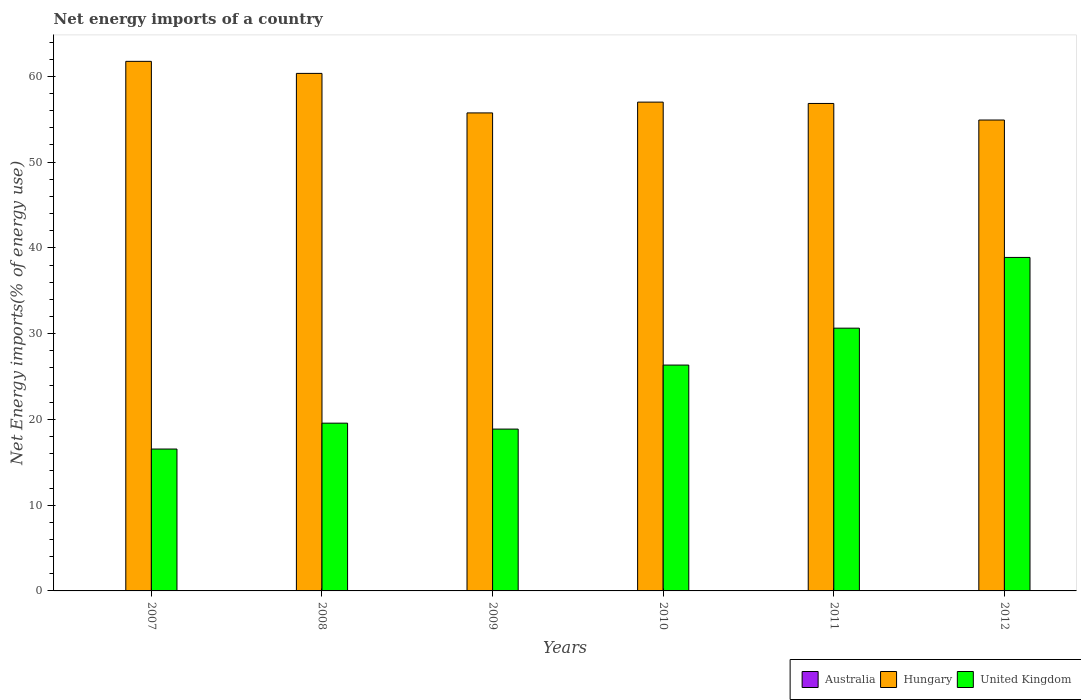Are the number of bars per tick equal to the number of legend labels?
Provide a succinct answer. No. Are the number of bars on each tick of the X-axis equal?
Provide a short and direct response. Yes. How many bars are there on the 2nd tick from the left?
Your answer should be very brief. 2. How many bars are there on the 1st tick from the right?
Provide a short and direct response. 2. What is the label of the 5th group of bars from the left?
Offer a terse response. 2011. In how many cases, is the number of bars for a given year not equal to the number of legend labels?
Make the answer very short. 6. Across all years, what is the maximum net energy imports in Hungary?
Your response must be concise. 61.75. Across all years, what is the minimum net energy imports in Australia?
Offer a very short reply. 0. In which year was the net energy imports in Hungary maximum?
Give a very brief answer. 2007. What is the total net energy imports in Hungary in the graph?
Make the answer very short. 346.56. What is the difference between the net energy imports in Hungary in 2011 and that in 2012?
Keep it short and to the point. 1.93. What is the difference between the net energy imports in United Kingdom in 2008 and the net energy imports in Hungary in 2009?
Keep it short and to the point. -36.18. What is the average net energy imports in United Kingdom per year?
Keep it short and to the point. 25.14. In the year 2008, what is the difference between the net energy imports in United Kingdom and net energy imports in Hungary?
Make the answer very short. -40.78. What is the ratio of the net energy imports in United Kingdom in 2007 to that in 2011?
Your answer should be compact. 0.54. Is the difference between the net energy imports in United Kingdom in 2007 and 2009 greater than the difference between the net energy imports in Hungary in 2007 and 2009?
Give a very brief answer. No. What is the difference between the highest and the second highest net energy imports in Hungary?
Offer a terse response. 1.4. What is the difference between the highest and the lowest net energy imports in Hungary?
Provide a short and direct response. 6.84. In how many years, is the net energy imports in Australia greater than the average net energy imports in Australia taken over all years?
Provide a succinct answer. 0. Is the sum of the net energy imports in Hungary in 2009 and 2011 greater than the maximum net energy imports in United Kingdom across all years?
Offer a very short reply. Yes. Is it the case that in every year, the sum of the net energy imports in Hungary and net energy imports in Australia is greater than the net energy imports in United Kingdom?
Give a very brief answer. Yes. How many bars are there?
Ensure brevity in your answer.  12. Are all the bars in the graph horizontal?
Provide a succinct answer. No. How many years are there in the graph?
Your answer should be very brief. 6. Are the values on the major ticks of Y-axis written in scientific E-notation?
Your answer should be compact. No. Does the graph contain any zero values?
Your response must be concise. Yes. Where does the legend appear in the graph?
Make the answer very short. Bottom right. How many legend labels are there?
Your answer should be very brief. 3. What is the title of the graph?
Offer a terse response. Net energy imports of a country. What is the label or title of the X-axis?
Offer a very short reply. Years. What is the label or title of the Y-axis?
Your answer should be compact. Net Energy imports(% of energy use). What is the Net Energy imports(% of energy use) of Hungary in 2007?
Your answer should be compact. 61.75. What is the Net Energy imports(% of energy use) of United Kingdom in 2007?
Your response must be concise. 16.54. What is the Net Energy imports(% of energy use) of Australia in 2008?
Offer a very short reply. 0. What is the Net Energy imports(% of energy use) of Hungary in 2008?
Your answer should be very brief. 60.34. What is the Net Energy imports(% of energy use) in United Kingdom in 2008?
Ensure brevity in your answer.  19.56. What is the Net Energy imports(% of energy use) in Australia in 2009?
Keep it short and to the point. 0. What is the Net Energy imports(% of energy use) of Hungary in 2009?
Offer a terse response. 55.74. What is the Net Energy imports(% of energy use) of United Kingdom in 2009?
Ensure brevity in your answer.  18.87. What is the Net Energy imports(% of energy use) in Australia in 2010?
Provide a succinct answer. 0. What is the Net Energy imports(% of energy use) in Hungary in 2010?
Provide a succinct answer. 56.99. What is the Net Energy imports(% of energy use) of United Kingdom in 2010?
Your answer should be very brief. 26.33. What is the Net Energy imports(% of energy use) of Australia in 2011?
Offer a terse response. 0. What is the Net Energy imports(% of energy use) of Hungary in 2011?
Offer a very short reply. 56.84. What is the Net Energy imports(% of energy use) of United Kingdom in 2011?
Ensure brevity in your answer.  30.64. What is the Net Energy imports(% of energy use) of Australia in 2012?
Offer a terse response. 0. What is the Net Energy imports(% of energy use) in Hungary in 2012?
Your answer should be very brief. 54.91. What is the Net Energy imports(% of energy use) in United Kingdom in 2012?
Offer a terse response. 38.88. Across all years, what is the maximum Net Energy imports(% of energy use) of Hungary?
Keep it short and to the point. 61.75. Across all years, what is the maximum Net Energy imports(% of energy use) of United Kingdom?
Offer a terse response. 38.88. Across all years, what is the minimum Net Energy imports(% of energy use) in Hungary?
Keep it short and to the point. 54.91. Across all years, what is the minimum Net Energy imports(% of energy use) in United Kingdom?
Your answer should be compact. 16.54. What is the total Net Energy imports(% of energy use) in Hungary in the graph?
Provide a succinct answer. 346.56. What is the total Net Energy imports(% of energy use) of United Kingdom in the graph?
Offer a terse response. 150.83. What is the difference between the Net Energy imports(% of energy use) in Hungary in 2007 and that in 2008?
Offer a terse response. 1.4. What is the difference between the Net Energy imports(% of energy use) of United Kingdom in 2007 and that in 2008?
Your answer should be very brief. -3.02. What is the difference between the Net Energy imports(% of energy use) in Hungary in 2007 and that in 2009?
Your answer should be very brief. 6.01. What is the difference between the Net Energy imports(% of energy use) of United Kingdom in 2007 and that in 2009?
Ensure brevity in your answer.  -2.33. What is the difference between the Net Energy imports(% of energy use) in Hungary in 2007 and that in 2010?
Provide a succinct answer. 4.75. What is the difference between the Net Energy imports(% of energy use) of United Kingdom in 2007 and that in 2010?
Keep it short and to the point. -9.79. What is the difference between the Net Energy imports(% of energy use) in Hungary in 2007 and that in 2011?
Provide a short and direct response. 4.91. What is the difference between the Net Energy imports(% of energy use) in United Kingdom in 2007 and that in 2011?
Your answer should be compact. -14.09. What is the difference between the Net Energy imports(% of energy use) in Hungary in 2007 and that in 2012?
Keep it short and to the point. 6.84. What is the difference between the Net Energy imports(% of energy use) in United Kingdom in 2007 and that in 2012?
Provide a succinct answer. -22.34. What is the difference between the Net Energy imports(% of energy use) of Hungary in 2008 and that in 2009?
Provide a succinct answer. 4.61. What is the difference between the Net Energy imports(% of energy use) of United Kingdom in 2008 and that in 2009?
Give a very brief answer. 0.69. What is the difference between the Net Energy imports(% of energy use) of Hungary in 2008 and that in 2010?
Provide a short and direct response. 3.35. What is the difference between the Net Energy imports(% of energy use) in United Kingdom in 2008 and that in 2010?
Offer a very short reply. -6.77. What is the difference between the Net Energy imports(% of energy use) of Hungary in 2008 and that in 2011?
Offer a terse response. 3.51. What is the difference between the Net Energy imports(% of energy use) of United Kingdom in 2008 and that in 2011?
Provide a succinct answer. -11.08. What is the difference between the Net Energy imports(% of energy use) in Hungary in 2008 and that in 2012?
Offer a very short reply. 5.43. What is the difference between the Net Energy imports(% of energy use) of United Kingdom in 2008 and that in 2012?
Keep it short and to the point. -19.32. What is the difference between the Net Energy imports(% of energy use) in Hungary in 2009 and that in 2010?
Provide a short and direct response. -1.26. What is the difference between the Net Energy imports(% of energy use) in United Kingdom in 2009 and that in 2010?
Your answer should be very brief. -7.46. What is the difference between the Net Energy imports(% of energy use) of Hungary in 2009 and that in 2011?
Offer a terse response. -1.1. What is the difference between the Net Energy imports(% of energy use) of United Kingdom in 2009 and that in 2011?
Make the answer very short. -11.77. What is the difference between the Net Energy imports(% of energy use) in Hungary in 2009 and that in 2012?
Make the answer very short. 0.83. What is the difference between the Net Energy imports(% of energy use) of United Kingdom in 2009 and that in 2012?
Keep it short and to the point. -20.01. What is the difference between the Net Energy imports(% of energy use) of Hungary in 2010 and that in 2011?
Your response must be concise. 0.16. What is the difference between the Net Energy imports(% of energy use) in United Kingdom in 2010 and that in 2011?
Offer a terse response. -4.3. What is the difference between the Net Energy imports(% of energy use) of Hungary in 2010 and that in 2012?
Ensure brevity in your answer.  2.09. What is the difference between the Net Energy imports(% of energy use) in United Kingdom in 2010 and that in 2012?
Ensure brevity in your answer.  -12.55. What is the difference between the Net Energy imports(% of energy use) of Hungary in 2011 and that in 2012?
Give a very brief answer. 1.93. What is the difference between the Net Energy imports(% of energy use) in United Kingdom in 2011 and that in 2012?
Provide a short and direct response. -8.25. What is the difference between the Net Energy imports(% of energy use) in Hungary in 2007 and the Net Energy imports(% of energy use) in United Kingdom in 2008?
Your answer should be very brief. 42.19. What is the difference between the Net Energy imports(% of energy use) of Hungary in 2007 and the Net Energy imports(% of energy use) of United Kingdom in 2009?
Offer a terse response. 42.88. What is the difference between the Net Energy imports(% of energy use) of Hungary in 2007 and the Net Energy imports(% of energy use) of United Kingdom in 2010?
Make the answer very short. 35.41. What is the difference between the Net Energy imports(% of energy use) in Hungary in 2007 and the Net Energy imports(% of energy use) in United Kingdom in 2011?
Your answer should be very brief. 31.11. What is the difference between the Net Energy imports(% of energy use) in Hungary in 2007 and the Net Energy imports(% of energy use) in United Kingdom in 2012?
Give a very brief answer. 22.86. What is the difference between the Net Energy imports(% of energy use) of Hungary in 2008 and the Net Energy imports(% of energy use) of United Kingdom in 2009?
Your answer should be compact. 41.47. What is the difference between the Net Energy imports(% of energy use) in Hungary in 2008 and the Net Energy imports(% of energy use) in United Kingdom in 2010?
Offer a very short reply. 34.01. What is the difference between the Net Energy imports(% of energy use) in Hungary in 2008 and the Net Energy imports(% of energy use) in United Kingdom in 2011?
Ensure brevity in your answer.  29.7. What is the difference between the Net Energy imports(% of energy use) in Hungary in 2008 and the Net Energy imports(% of energy use) in United Kingdom in 2012?
Provide a short and direct response. 21.46. What is the difference between the Net Energy imports(% of energy use) of Hungary in 2009 and the Net Energy imports(% of energy use) of United Kingdom in 2010?
Provide a succinct answer. 29.4. What is the difference between the Net Energy imports(% of energy use) of Hungary in 2009 and the Net Energy imports(% of energy use) of United Kingdom in 2011?
Provide a short and direct response. 25.1. What is the difference between the Net Energy imports(% of energy use) of Hungary in 2009 and the Net Energy imports(% of energy use) of United Kingdom in 2012?
Keep it short and to the point. 16.85. What is the difference between the Net Energy imports(% of energy use) of Hungary in 2010 and the Net Energy imports(% of energy use) of United Kingdom in 2011?
Make the answer very short. 26.36. What is the difference between the Net Energy imports(% of energy use) in Hungary in 2010 and the Net Energy imports(% of energy use) in United Kingdom in 2012?
Your answer should be very brief. 18.11. What is the difference between the Net Energy imports(% of energy use) of Hungary in 2011 and the Net Energy imports(% of energy use) of United Kingdom in 2012?
Provide a succinct answer. 17.95. What is the average Net Energy imports(% of energy use) of Hungary per year?
Ensure brevity in your answer.  57.76. What is the average Net Energy imports(% of energy use) in United Kingdom per year?
Give a very brief answer. 25.14. In the year 2007, what is the difference between the Net Energy imports(% of energy use) in Hungary and Net Energy imports(% of energy use) in United Kingdom?
Ensure brevity in your answer.  45.2. In the year 2008, what is the difference between the Net Energy imports(% of energy use) of Hungary and Net Energy imports(% of energy use) of United Kingdom?
Your response must be concise. 40.78. In the year 2009, what is the difference between the Net Energy imports(% of energy use) of Hungary and Net Energy imports(% of energy use) of United Kingdom?
Provide a succinct answer. 36.87. In the year 2010, what is the difference between the Net Energy imports(% of energy use) of Hungary and Net Energy imports(% of energy use) of United Kingdom?
Make the answer very short. 30.66. In the year 2011, what is the difference between the Net Energy imports(% of energy use) in Hungary and Net Energy imports(% of energy use) in United Kingdom?
Ensure brevity in your answer.  26.2. In the year 2012, what is the difference between the Net Energy imports(% of energy use) of Hungary and Net Energy imports(% of energy use) of United Kingdom?
Provide a short and direct response. 16.02. What is the ratio of the Net Energy imports(% of energy use) in Hungary in 2007 to that in 2008?
Offer a very short reply. 1.02. What is the ratio of the Net Energy imports(% of energy use) in United Kingdom in 2007 to that in 2008?
Provide a short and direct response. 0.85. What is the ratio of the Net Energy imports(% of energy use) of Hungary in 2007 to that in 2009?
Offer a terse response. 1.11. What is the ratio of the Net Energy imports(% of energy use) of United Kingdom in 2007 to that in 2009?
Your answer should be compact. 0.88. What is the ratio of the Net Energy imports(% of energy use) in Hungary in 2007 to that in 2010?
Your response must be concise. 1.08. What is the ratio of the Net Energy imports(% of energy use) in United Kingdom in 2007 to that in 2010?
Ensure brevity in your answer.  0.63. What is the ratio of the Net Energy imports(% of energy use) in Hungary in 2007 to that in 2011?
Your response must be concise. 1.09. What is the ratio of the Net Energy imports(% of energy use) in United Kingdom in 2007 to that in 2011?
Your response must be concise. 0.54. What is the ratio of the Net Energy imports(% of energy use) of Hungary in 2007 to that in 2012?
Your answer should be compact. 1.12. What is the ratio of the Net Energy imports(% of energy use) in United Kingdom in 2007 to that in 2012?
Offer a terse response. 0.43. What is the ratio of the Net Energy imports(% of energy use) of Hungary in 2008 to that in 2009?
Offer a terse response. 1.08. What is the ratio of the Net Energy imports(% of energy use) of United Kingdom in 2008 to that in 2009?
Ensure brevity in your answer.  1.04. What is the ratio of the Net Energy imports(% of energy use) in Hungary in 2008 to that in 2010?
Give a very brief answer. 1.06. What is the ratio of the Net Energy imports(% of energy use) in United Kingdom in 2008 to that in 2010?
Keep it short and to the point. 0.74. What is the ratio of the Net Energy imports(% of energy use) of Hungary in 2008 to that in 2011?
Make the answer very short. 1.06. What is the ratio of the Net Energy imports(% of energy use) in United Kingdom in 2008 to that in 2011?
Offer a terse response. 0.64. What is the ratio of the Net Energy imports(% of energy use) in Hungary in 2008 to that in 2012?
Make the answer very short. 1.1. What is the ratio of the Net Energy imports(% of energy use) of United Kingdom in 2008 to that in 2012?
Provide a succinct answer. 0.5. What is the ratio of the Net Energy imports(% of energy use) in Hungary in 2009 to that in 2010?
Keep it short and to the point. 0.98. What is the ratio of the Net Energy imports(% of energy use) of United Kingdom in 2009 to that in 2010?
Your response must be concise. 0.72. What is the ratio of the Net Energy imports(% of energy use) of Hungary in 2009 to that in 2011?
Your answer should be compact. 0.98. What is the ratio of the Net Energy imports(% of energy use) in United Kingdom in 2009 to that in 2011?
Your answer should be compact. 0.62. What is the ratio of the Net Energy imports(% of energy use) in Hungary in 2009 to that in 2012?
Offer a very short reply. 1.02. What is the ratio of the Net Energy imports(% of energy use) in United Kingdom in 2009 to that in 2012?
Give a very brief answer. 0.49. What is the ratio of the Net Energy imports(% of energy use) of Hungary in 2010 to that in 2011?
Provide a short and direct response. 1. What is the ratio of the Net Energy imports(% of energy use) of United Kingdom in 2010 to that in 2011?
Your answer should be very brief. 0.86. What is the ratio of the Net Energy imports(% of energy use) in Hungary in 2010 to that in 2012?
Ensure brevity in your answer.  1.04. What is the ratio of the Net Energy imports(% of energy use) of United Kingdom in 2010 to that in 2012?
Provide a short and direct response. 0.68. What is the ratio of the Net Energy imports(% of energy use) in Hungary in 2011 to that in 2012?
Your response must be concise. 1.04. What is the ratio of the Net Energy imports(% of energy use) of United Kingdom in 2011 to that in 2012?
Give a very brief answer. 0.79. What is the difference between the highest and the second highest Net Energy imports(% of energy use) in Hungary?
Your answer should be very brief. 1.4. What is the difference between the highest and the second highest Net Energy imports(% of energy use) in United Kingdom?
Provide a succinct answer. 8.25. What is the difference between the highest and the lowest Net Energy imports(% of energy use) in Hungary?
Give a very brief answer. 6.84. What is the difference between the highest and the lowest Net Energy imports(% of energy use) of United Kingdom?
Provide a succinct answer. 22.34. 